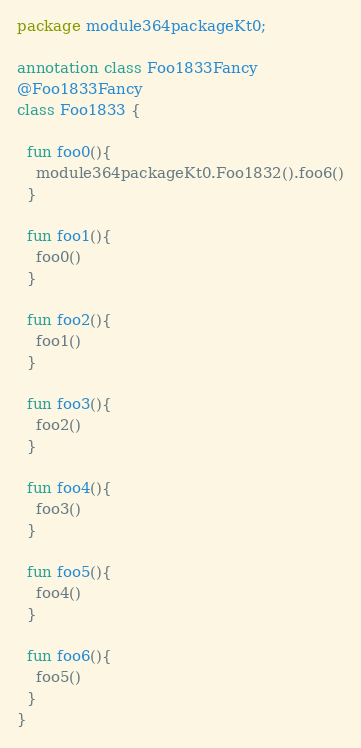<code> <loc_0><loc_0><loc_500><loc_500><_Kotlin_>package module364packageKt0;

annotation class Foo1833Fancy
@Foo1833Fancy
class Foo1833 {

  fun foo0(){
    module364packageKt0.Foo1832().foo6()
  }

  fun foo1(){
    foo0()
  }

  fun foo2(){
    foo1()
  }

  fun foo3(){
    foo2()
  }

  fun foo4(){
    foo3()
  }

  fun foo5(){
    foo4()
  }

  fun foo6(){
    foo5()
  }
}</code> 